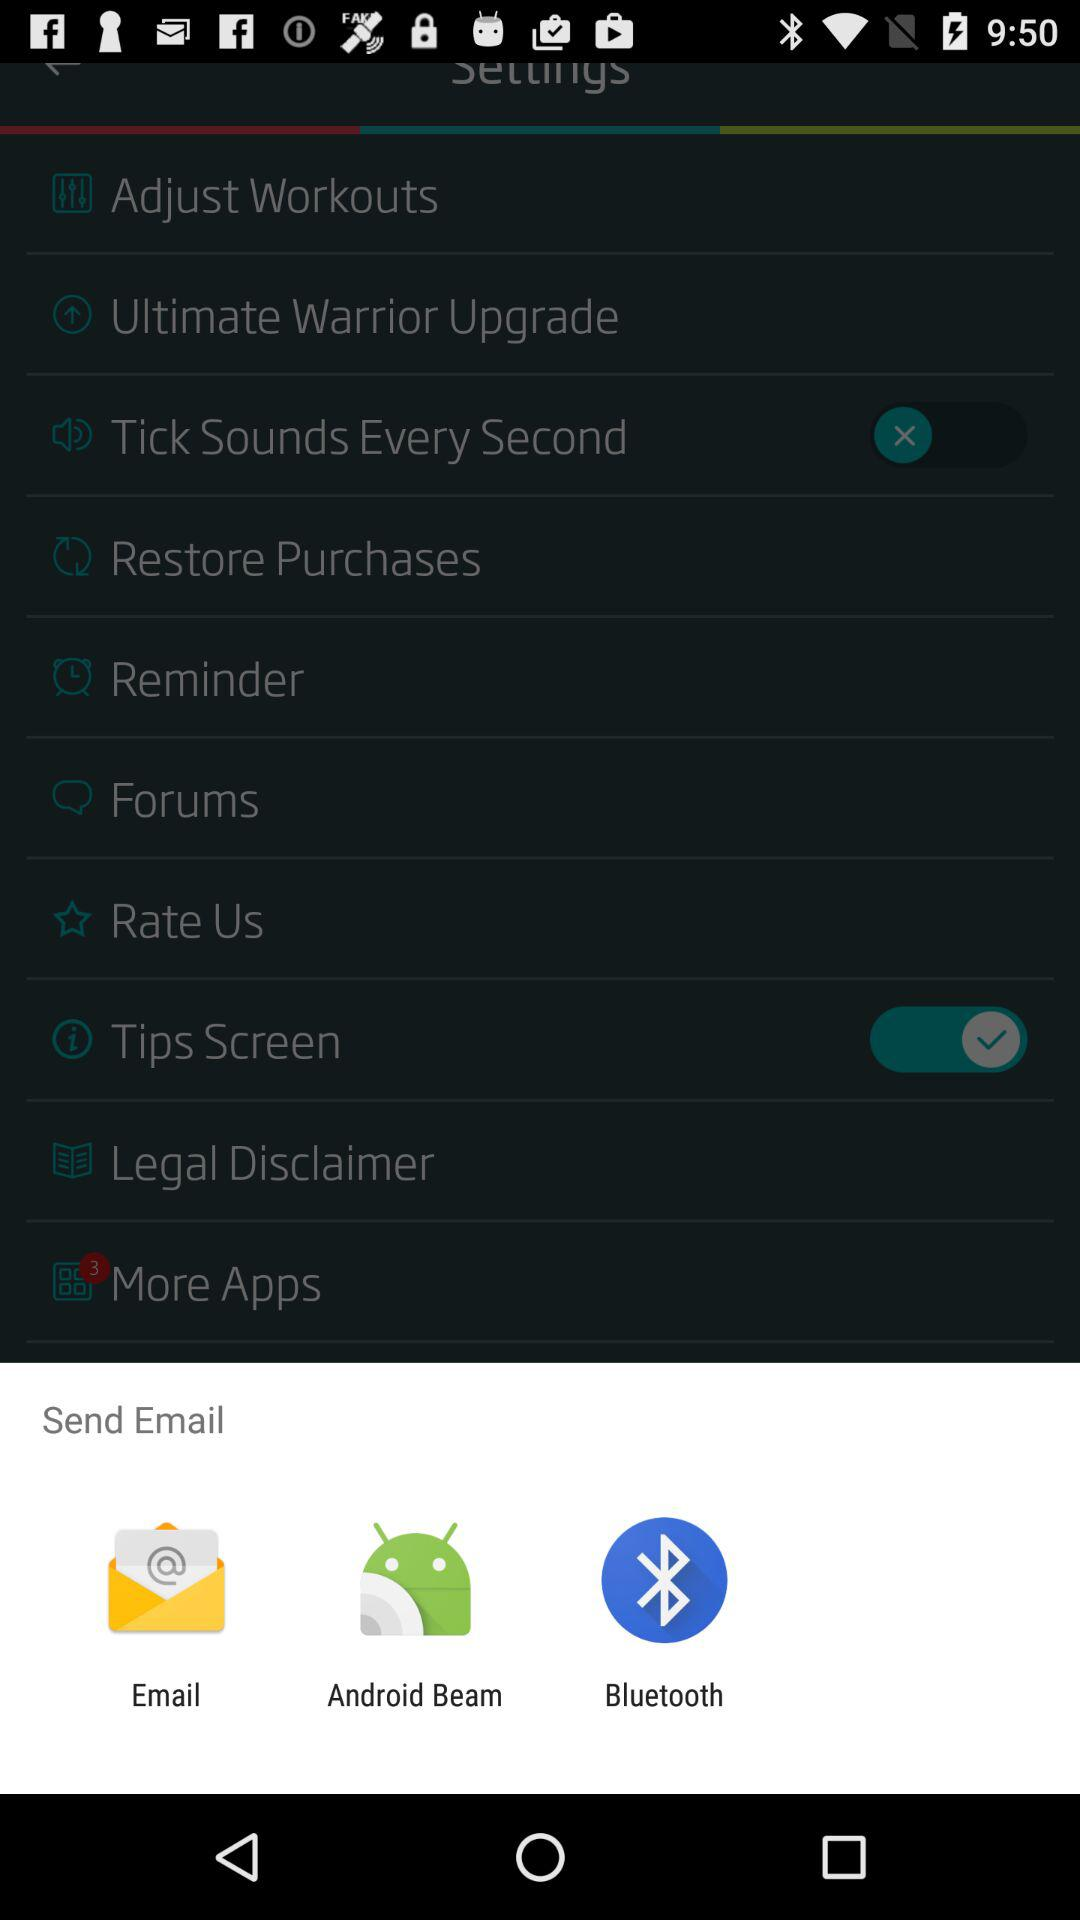Through which application can we send an email? You can send an email through "Email", "Android Beam" and "Bluetooth". 